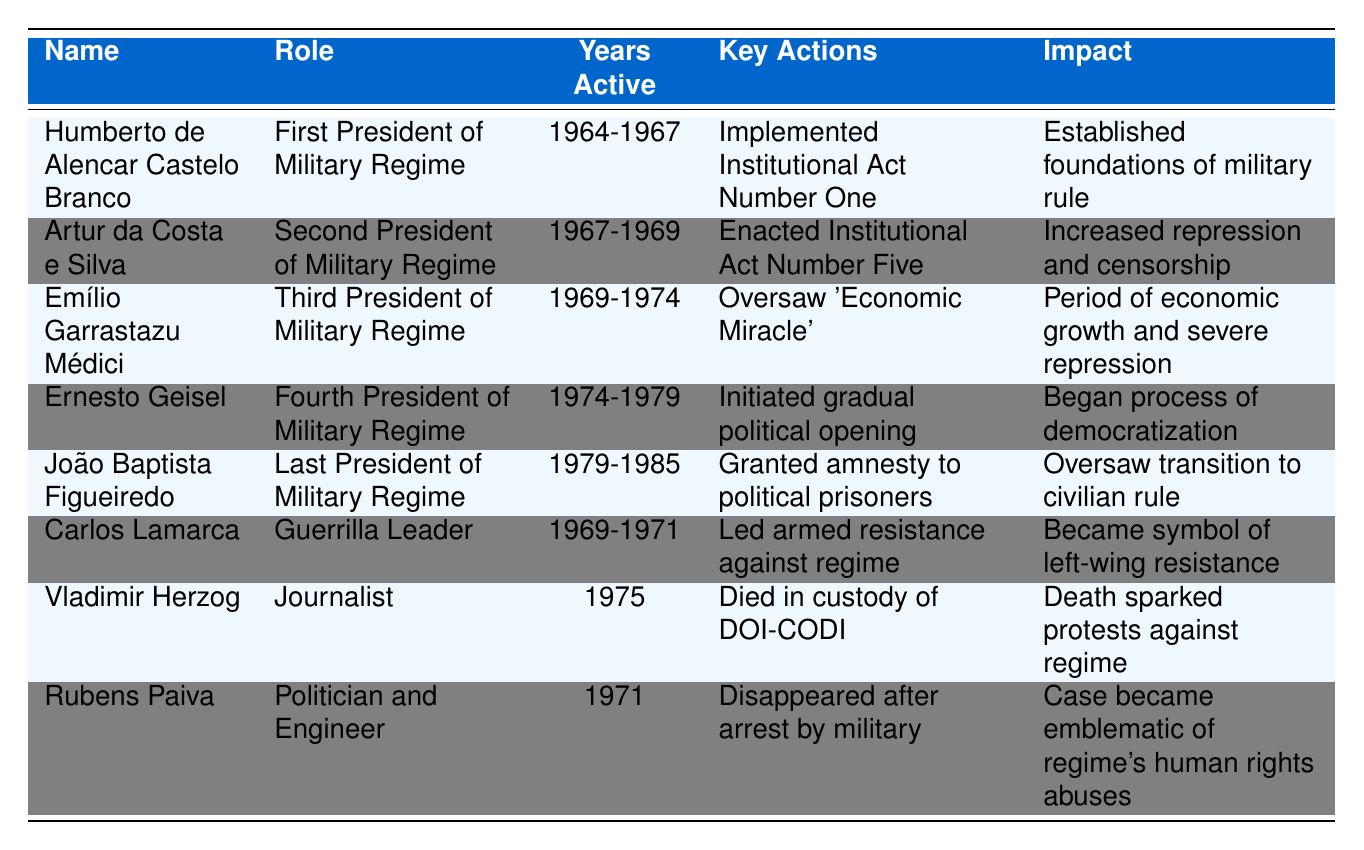What years was Humberto de Alencar Castelo Branco active as president? According to the table, Humberto de Alencar Castelo Branco was active from 1964 to 1967.
Answer: 1964-1967 What role did Emílio Garrastazu Médici play during the military dictatorship? The table lists Emílio Garrastazu Médici as the Third President of the Military Regime.
Answer: Third President of Military Regime Who enacted Institutional Act Number Five? The table states that Artur da Costa e Silva enacted Institutional Act Number Five during his presidency from 1967 to 1969.
Answer: Artur da Costa e Silva How many years was João Baptista Figueiredo in power? João Baptista Figueiredo was in power from 1979 to 1985, which makes it 6 years.
Answer: 6 years Which key action is associated with Carlos Lamarca? The table indicates that Carlos Lamarca led armed resistance against the regime during his active years from 1969 to 1971.
Answer: Led armed resistance against regime Did Vladimir Herzog die in custody? Yes, the table confirms that Vladimir Herzog died in custody of DOI-CODI.
Answer: Yes What was the impact of Ernesto Geisel's presidency? The table shows that Ernesto Geisel's presidency initiated a gradual political opening, marking the beginning of the democratization process.
Answer: Began process of democratization Which key figure has the highest years active in the military regime? By reviewing the years active, we see João Baptista Figueiredo (1979-1985) has 6 years, while others have less, indicating he has the highest.
Answer: João Baptista Figueiredo What can we infer about the impact of Emílio Garrastazu Médici's actions? The impact of Emílio Garrastazu Médici's actions, as stated in the table, suggested a period of economic growth coupled with severe repression, showcasing the dual nature of his presidency.
Answer: Economic growth and severe repression How did Rubens Paiva’s fate contribute to understanding the military regime's human rights abuses? The table notes that Rubens Paiva disappeared after arrest, which has become emblematic of the regime's human rights abuses, thus highlighting the severity of the regime’s actions.
Answer: Emblematic of regime's human rights abuses 